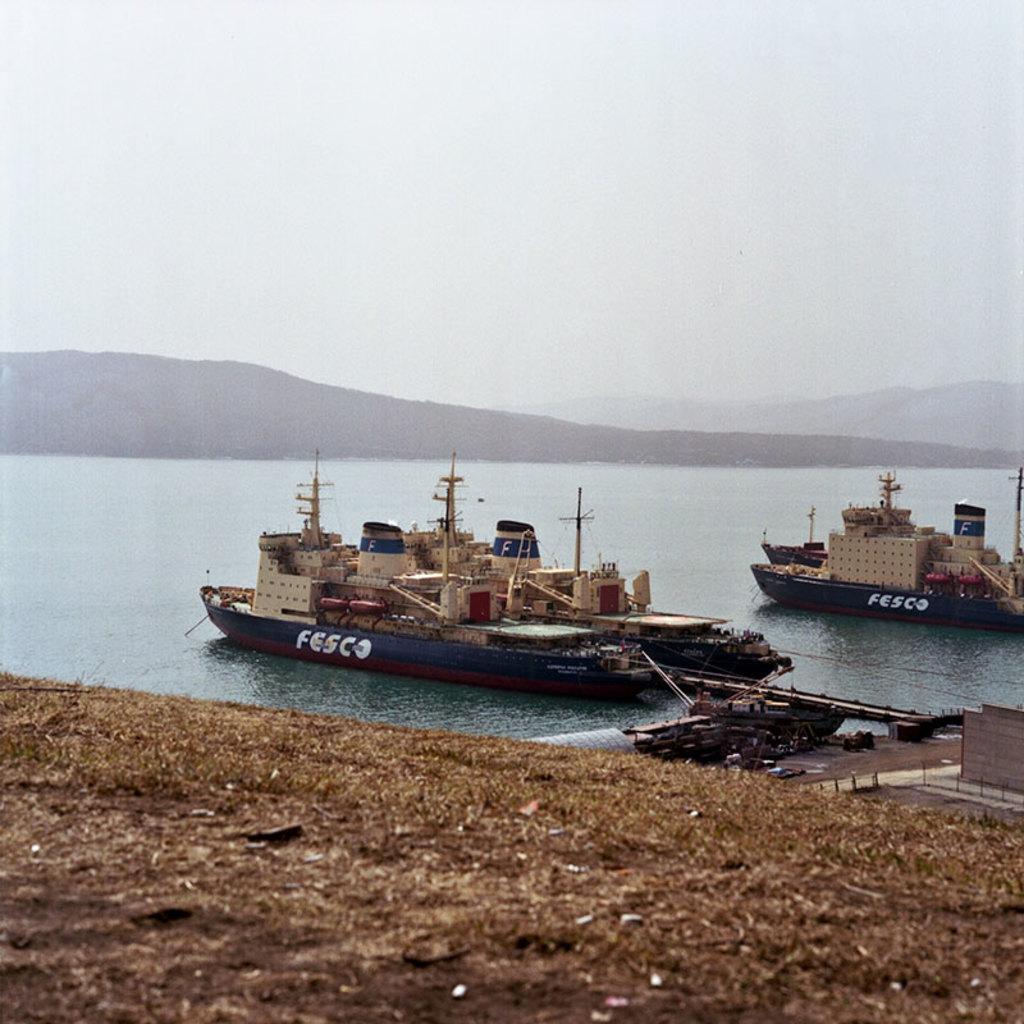Which company owns these boats?
Give a very brief answer. Fesco. 